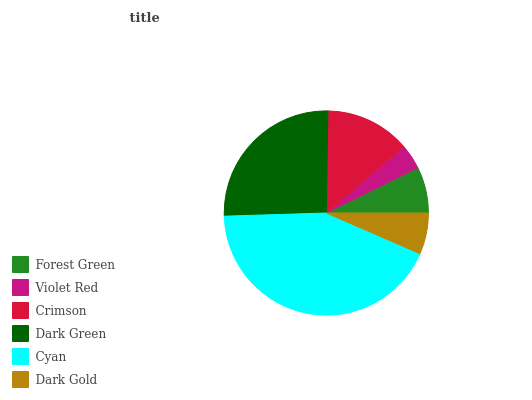Is Violet Red the minimum?
Answer yes or no. Yes. Is Cyan the maximum?
Answer yes or no. Yes. Is Crimson the minimum?
Answer yes or no. No. Is Crimson the maximum?
Answer yes or no. No. Is Crimson greater than Violet Red?
Answer yes or no. Yes. Is Violet Red less than Crimson?
Answer yes or no. Yes. Is Violet Red greater than Crimson?
Answer yes or no. No. Is Crimson less than Violet Red?
Answer yes or no. No. Is Crimson the high median?
Answer yes or no. Yes. Is Forest Green the low median?
Answer yes or no. Yes. Is Dark Gold the high median?
Answer yes or no. No. Is Crimson the low median?
Answer yes or no. No. 